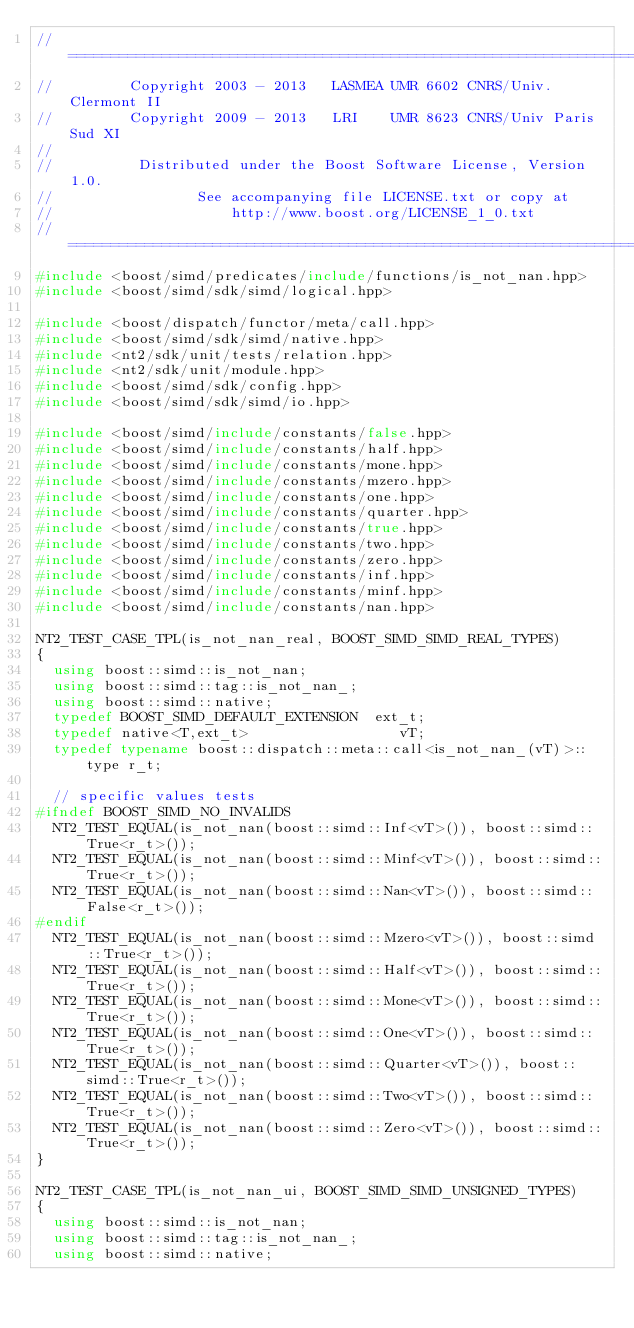Convert code to text. <code><loc_0><loc_0><loc_500><loc_500><_C++_>//==============================================================================
//         Copyright 2003 - 2013   LASMEA UMR 6602 CNRS/Univ. Clermont II
//         Copyright 2009 - 2013   LRI    UMR 8623 CNRS/Univ Paris Sud XI
//
//          Distributed under the Boost Software License, Version 1.0.
//                 See accompanying file LICENSE.txt or copy at
//                     http://www.boost.org/LICENSE_1_0.txt
//==============================================================================
#include <boost/simd/predicates/include/functions/is_not_nan.hpp>
#include <boost/simd/sdk/simd/logical.hpp>

#include <boost/dispatch/functor/meta/call.hpp>
#include <boost/simd/sdk/simd/native.hpp>
#include <nt2/sdk/unit/tests/relation.hpp>
#include <nt2/sdk/unit/module.hpp>
#include <boost/simd/sdk/config.hpp>
#include <boost/simd/sdk/simd/io.hpp>

#include <boost/simd/include/constants/false.hpp>
#include <boost/simd/include/constants/half.hpp>
#include <boost/simd/include/constants/mone.hpp>
#include <boost/simd/include/constants/mzero.hpp>
#include <boost/simd/include/constants/one.hpp>
#include <boost/simd/include/constants/quarter.hpp>
#include <boost/simd/include/constants/true.hpp>
#include <boost/simd/include/constants/two.hpp>
#include <boost/simd/include/constants/zero.hpp>
#include <boost/simd/include/constants/inf.hpp>
#include <boost/simd/include/constants/minf.hpp>
#include <boost/simd/include/constants/nan.hpp>

NT2_TEST_CASE_TPL(is_not_nan_real, BOOST_SIMD_SIMD_REAL_TYPES)
{
  using boost::simd::is_not_nan;
  using boost::simd::tag::is_not_nan_;
  using boost::simd::native;
  typedef BOOST_SIMD_DEFAULT_EXTENSION  ext_t;
  typedef native<T,ext_t>                  vT;
  typedef typename boost::dispatch::meta::call<is_not_nan_(vT)>::type r_t;

  // specific values tests
#ifndef BOOST_SIMD_NO_INVALIDS
  NT2_TEST_EQUAL(is_not_nan(boost::simd::Inf<vT>()), boost::simd::True<r_t>());
  NT2_TEST_EQUAL(is_not_nan(boost::simd::Minf<vT>()), boost::simd::True<r_t>());
  NT2_TEST_EQUAL(is_not_nan(boost::simd::Nan<vT>()), boost::simd::False<r_t>());
#endif
  NT2_TEST_EQUAL(is_not_nan(boost::simd::Mzero<vT>()), boost::simd::True<r_t>());
  NT2_TEST_EQUAL(is_not_nan(boost::simd::Half<vT>()), boost::simd::True<r_t>());
  NT2_TEST_EQUAL(is_not_nan(boost::simd::Mone<vT>()), boost::simd::True<r_t>());
  NT2_TEST_EQUAL(is_not_nan(boost::simd::One<vT>()), boost::simd::True<r_t>());
  NT2_TEST_EQUAL(is_not_nan(boost::simd::Quarter<vT>()), boost::simd::True<r_t>());
  NT2_TEST_EQUAL(is_not_nan(boost::simd::Two<vT>()), boost::simd::True<r_t>());
  NT2_TEST_EQUAL(is_not_nan(boost::simd::Zero<vT>()), boost::simd::True<r_t>());
}

NT2_TEST_CASE_TPL(is_not_nan_ui, BOOST_SIMD_SIMD_UNSIGNED_TYPES)
{
  using boost::simd::is_not_nan;
  using boost::simd::tag::is_not_nan_;
  using boost::simd::native;</code> 